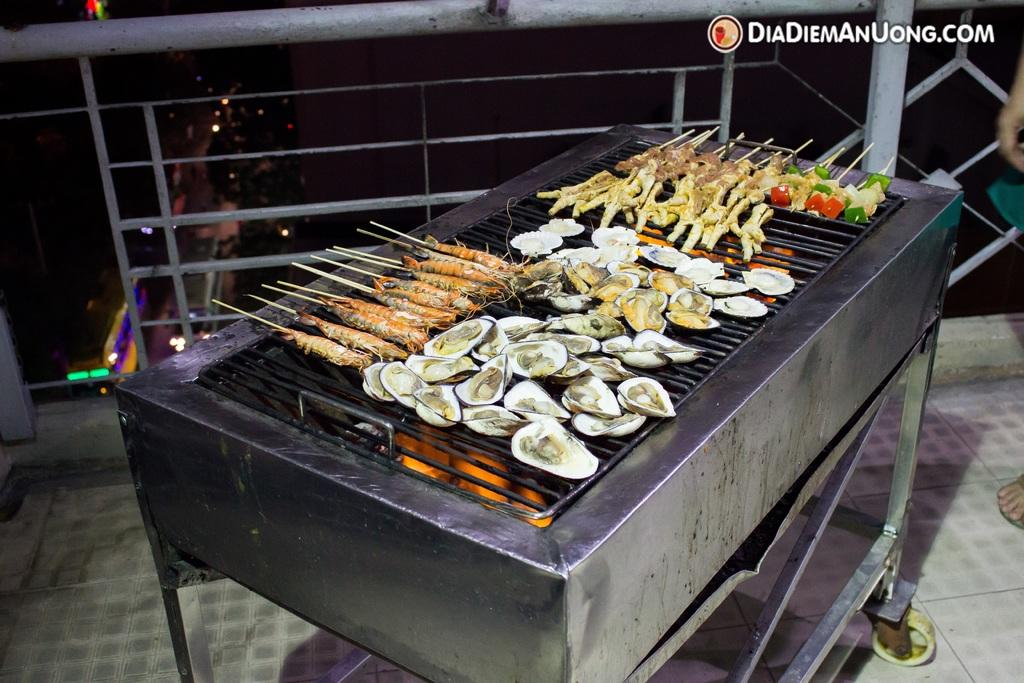<image>
Write a terse but informative summary of the picture. a bunch of food cooking on the girl and the website DiaDiemAnUong.com at the top 